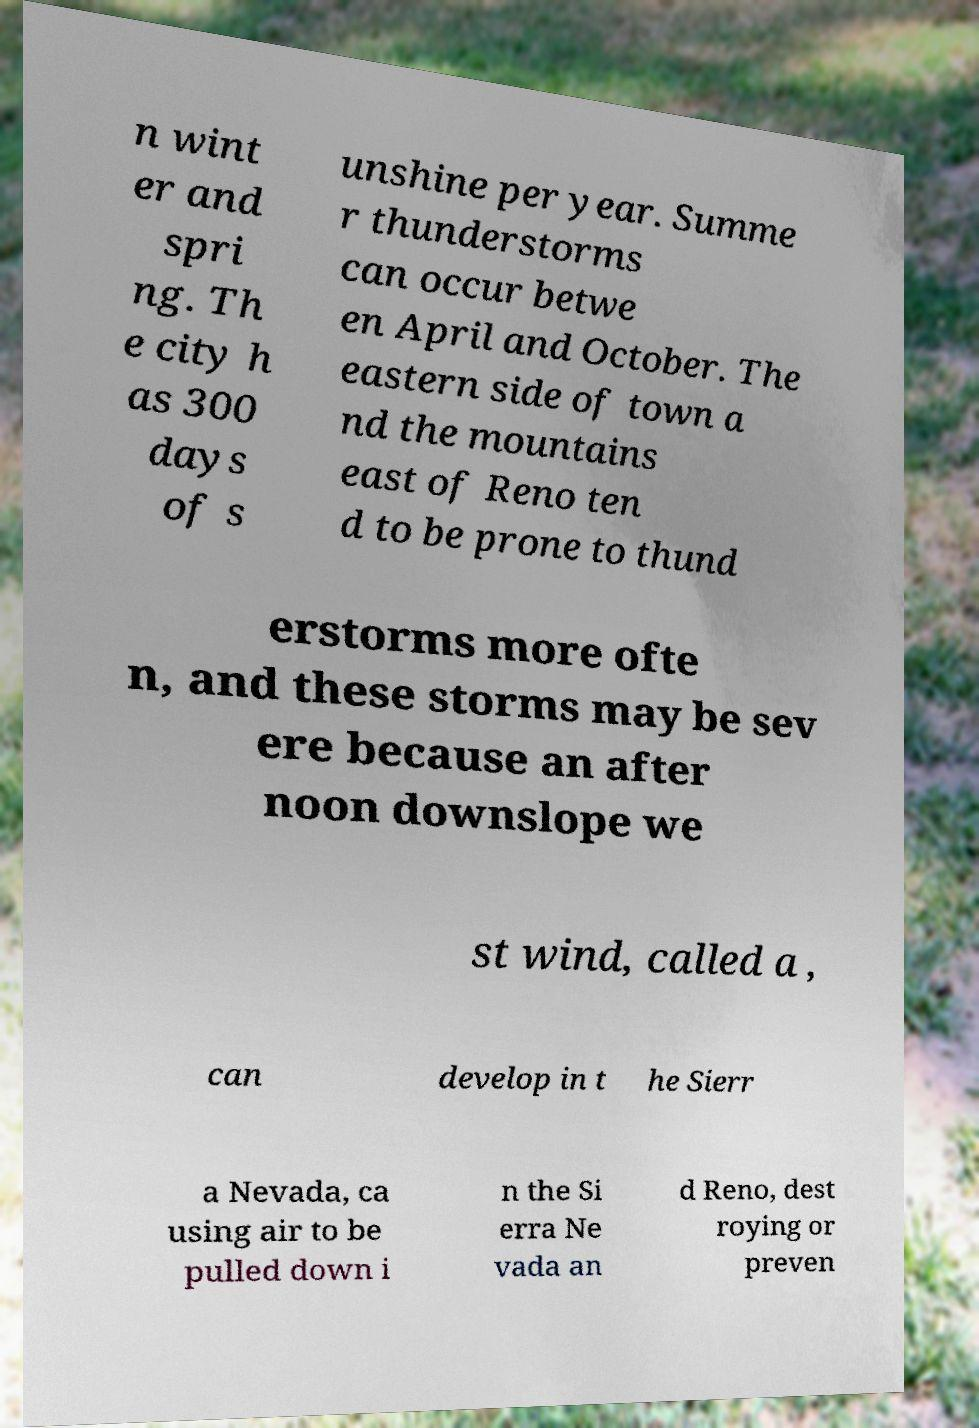Can you accurately transcribe the text from the provided image for me? n wint er and spri ng. Th e city h as 300 days of s unshine per year. Summe r thunderstorms can occur betwe en April and October. The eastern side of town a nd the mountains east of Reno ten d to be prone to thund erstorms more ofte n, and these storms may be sev ere because an after noon downslope we st wind, called a , can develop in t he Sierr a Nevada, ca using air to be pulled down i n the Si erra Ne vada an d Reno, dest roying or preven 